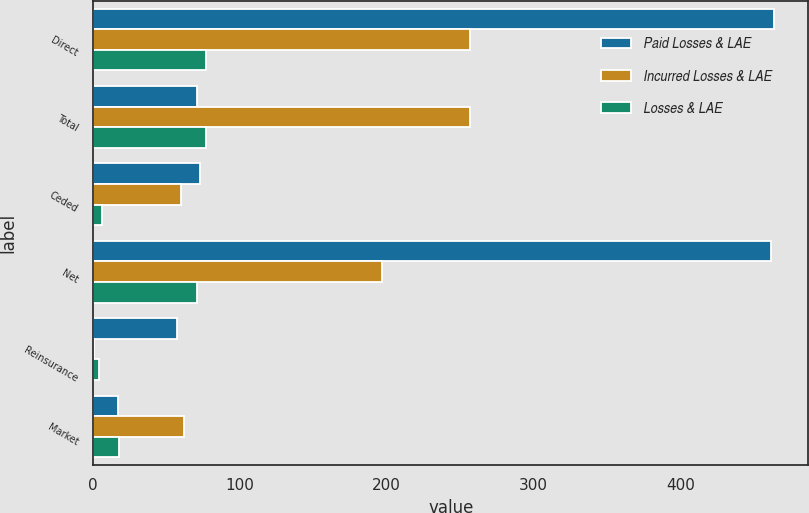Convert chart. <chart><loc_0><loc_0><loc_500><loc_500><stacked_bar_chart><ecel><fcel>Direct<fcel>Total<fcel>Ceded<fcel>Net<fcel>Reinsurance<fcel>Market<nl><fcel>Paid Losses & LAE<fcel>464<fcel>71<fcel>73<fcel>462<fcel>57<fcel>17<nl><fcel>Incurred Losses & LAE<fcel>257<fcel>257<fcel>60<fcel>197<fcel>1<fcel>62<nl><fcel>Losses & LAE<fcel>77<fcel>77<fcel>6<fcel>71<fcel>4<fcel>18<nl></chart> 